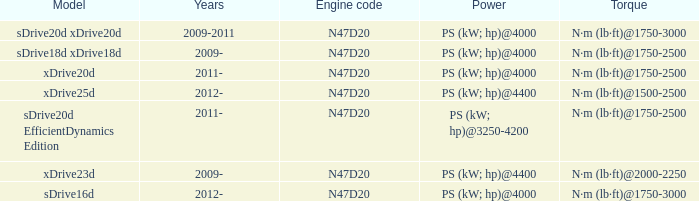What years did the sdrive16d model have a Torque of n·m (lb·ft)@1750-3000? 2012-. 